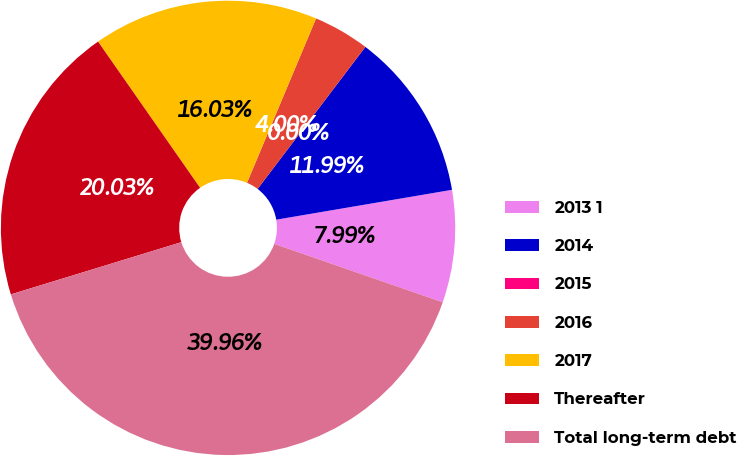<chart> <loc_0><loc_0><loc_500><loc_500><pie_chart><fcel>2013 1<fcel>2014<fcel>2015<fcel>2016<fcel>2017<fcel>Thereafter<fcel>Total long-term debt<nl><fcel>7.99%<fcel>11.99%<fcel>0.0%<fcel>4.0%<fcel>16.03%<fcel>20.03%<fcel>39.96%<nl></chart> 